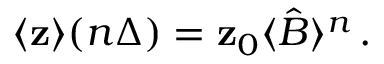Convert formula to latex. <formula><loc_0><loc_0><loc_500><loc_500>\langle { z } \rangle ( n \Delta ) = { z } _ { 0 } \langle \hat { B } \rangle ^ { n } \, .</formula> 